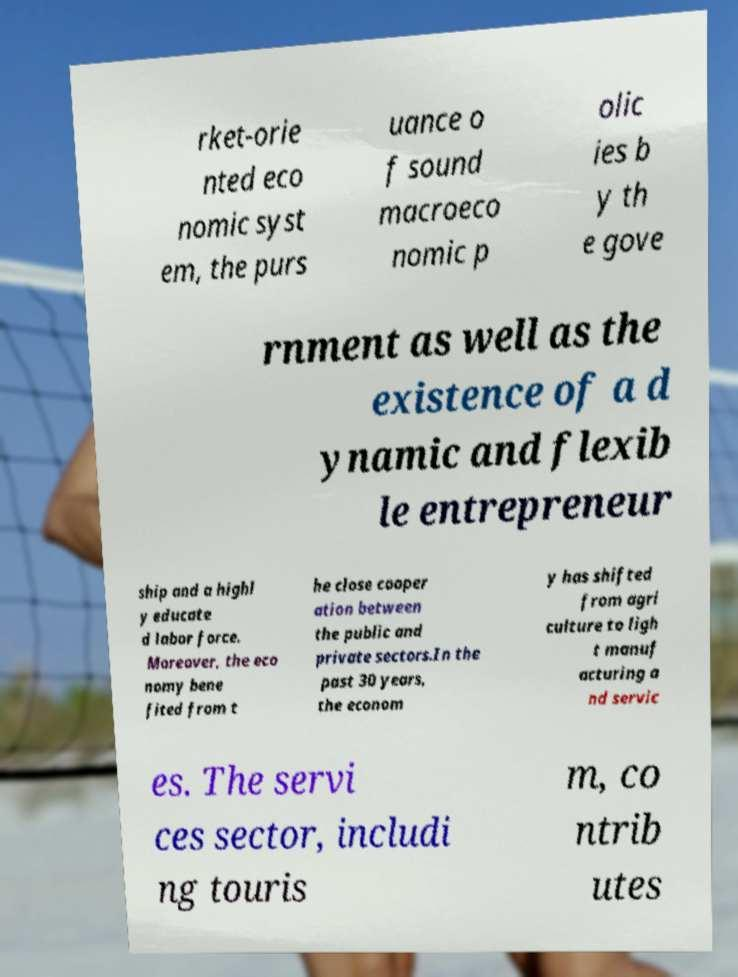Can you accurately transcribe the text from the provided image for me? rket-orie nted eco nomic syst em, the purs uance o f sound macroeco nomic p olic ies b y th e gove rnment as well as the existence of a d ynamic and flexib le entrepreneur ship and a highl y educate d labor force. Moreover, the eco nomy bene fited from t he close cooper ation between the public and private sectors.In the past 30 years, the econom y has shifted from agri culture to ligh t manuf acturing a nd servic es. The servi ces sector, includi ng touris m, co ntrib utes 